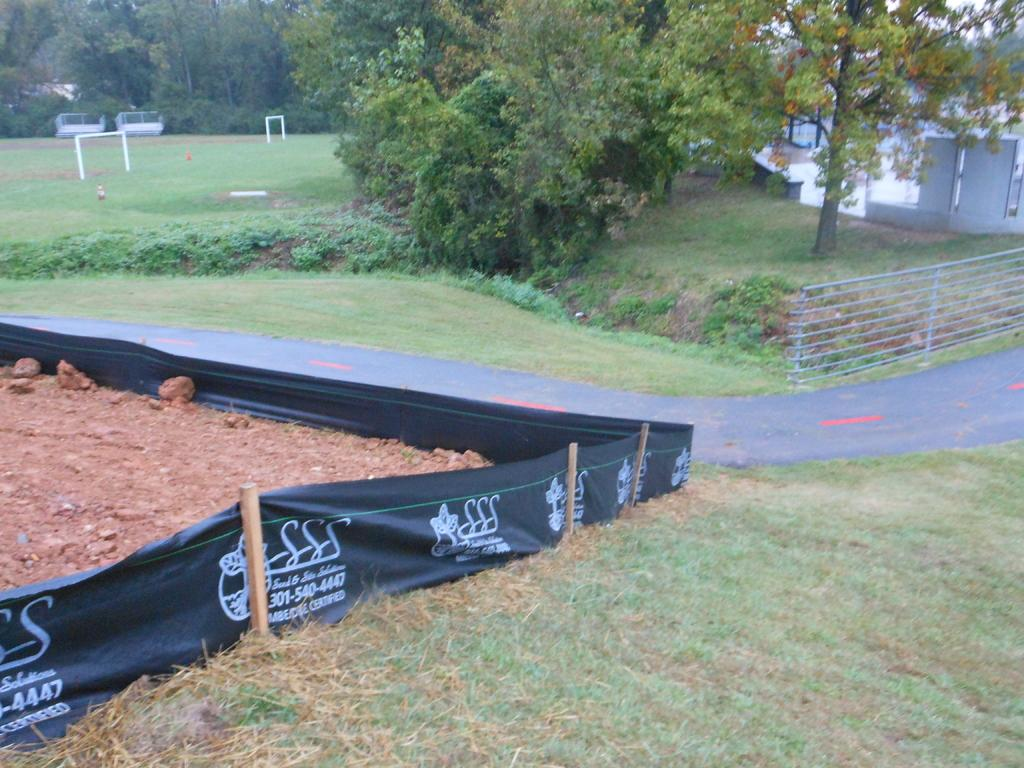What type of vegetation is present in the image? There is grass in the image. What structure can be seen in the image? There is a fence in the image. What other natural elements are visible in the image? There are trees in the image. What type of building is present in the image? There is a house in the image. What type of cast is visible on the tree in the image? There is no cast present on any tree in the image. What arithmetic problem is being solved on the grass in the image? There is no arithmetic problem being solved in the image; it only features grass, a fence, trees, and a house. 